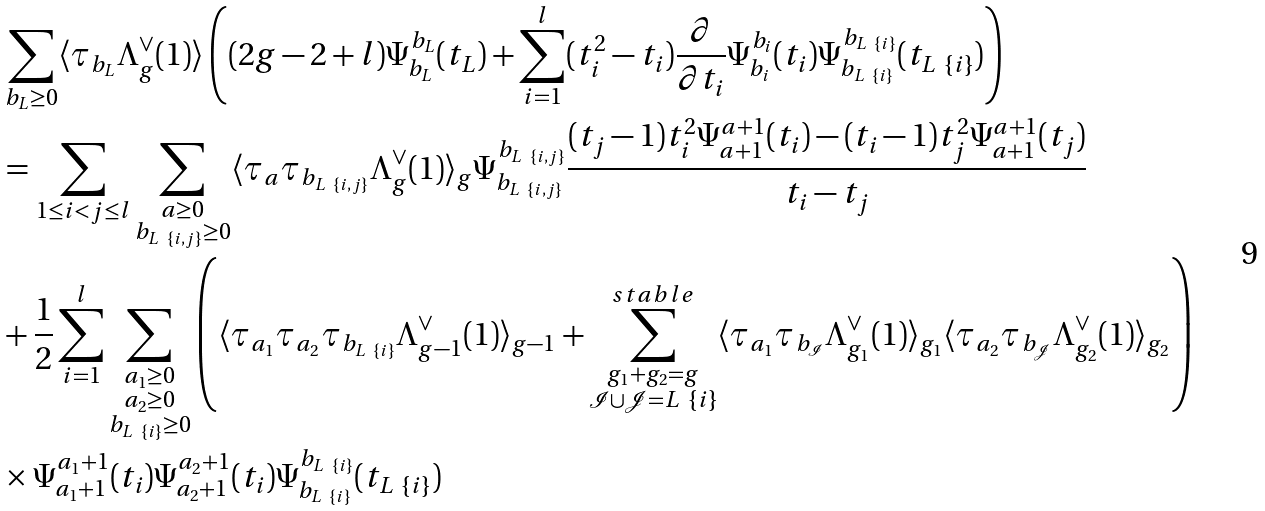Convert formula to latex. <formula><loc_0><loc_0><loc_500><loc_500>& \sum _ { b _ { L } \geq 0 } \langle \tau _ { b _ { L } } \Lambda _ { g } ^ { \vee } ( 1 ) \rangle \left ( ( 2 g - 2 + l ) \Psi _ { b _ { L } } ^ { b _ { L } } ( t _ { L } ) + \sum _ { i = 1 } ^ { l } ( t _ { i } ^ { 2 } - t _ { i } ) \frac { \partial } { \partial t _ { i } } \Psi _ { b _ { i } } ^ { b _ { i } } ( t _ { i } ) \Psi _ { b _ { L \ \{ i \} } } ^ { b _ { L \ \{ i \} } } ( t _ { L \ \{ i \} } ) \right ) \\ & = \sum _ { 1 \leq i < j \leq l } \sum _ { \substack { a \geq 0 \\ b _ { L \ \{ i , j \} } \geq 0 } } \langle \tau _ { a } \tau _ { b _ { L \ \{ i , j \} } } \Lambda _ { g } ^ { \vee } ( 1 ) \rangle _ { g } \Psi _ { b _ { L \ \{ i , j \} } } ^ { b _ { L \ \{ i , j \} } } \frac { ( t _ { j } - 1 ) t _ { i } ^ { 2 } \Psi _ { a + 1 } ^ { a + 1 } ( t _ { i } ) - ( t _ { i } - 1 ) t _ { j } ^ { 2 } \Psi _ { a + 1 } ^ { a + 1 } ( t _ { j } ) } { t _ { i } - t _ { j } } \\ & + \frac { 1 } { 2 } \sum _ { i = 1 } ^ { l } \sum _ { \substack { a _ { 1 } \geq 0 \\ a _ { 2 } \geq 0 \\ b _ { L \ \{ i \} } \geq 0 } } \left ( \langle \tau _ { a _ { 1 } } \tau _ { a _ { 2 } } \tau _ { b _ { L \ \{ i \} } } \Lambda _ { g - 1 } ^ { \vee } ( 1 ) \rangle _ { g - 1 } + \sum _ { \substack { g _ { 1 } + g _ { 2 } = g \\ \mathcal { I } \cup \mathcal { J } = L \ \{ i \} } } ^ { s t a b l e } \langle \tau _ { a _ { 1 } } \tau _ { b _ { \mathcal { I } } } \Lambda _ { g _ { 1 } } ^ { \vee } ( 1 ) \rangle _ { g _ { 1 } } \langle \tau _ { a _ { 2 } } \tau _ { b _ { \mathcal { J } } } \Lambda _ { g _ { 2 } } ^ { \vee } ( 1 ) \rangle _ { g _ { 2 } } \right ) \\ & \times \Psi _ { a _ { 1 } + 1 } ^ { a _ { 1 } + 1 } ( t _ { i } ) \Psi _ { a _ { 2 } + 1 } ^ { a _ { 2 } + 1 } ( t _ { i } ) \Psi _ { b _ { L \ \{ i \} } } ^ { b _ { L \ \{ i \} } } ( t _ { L \ \{ i \} } )</formula> 